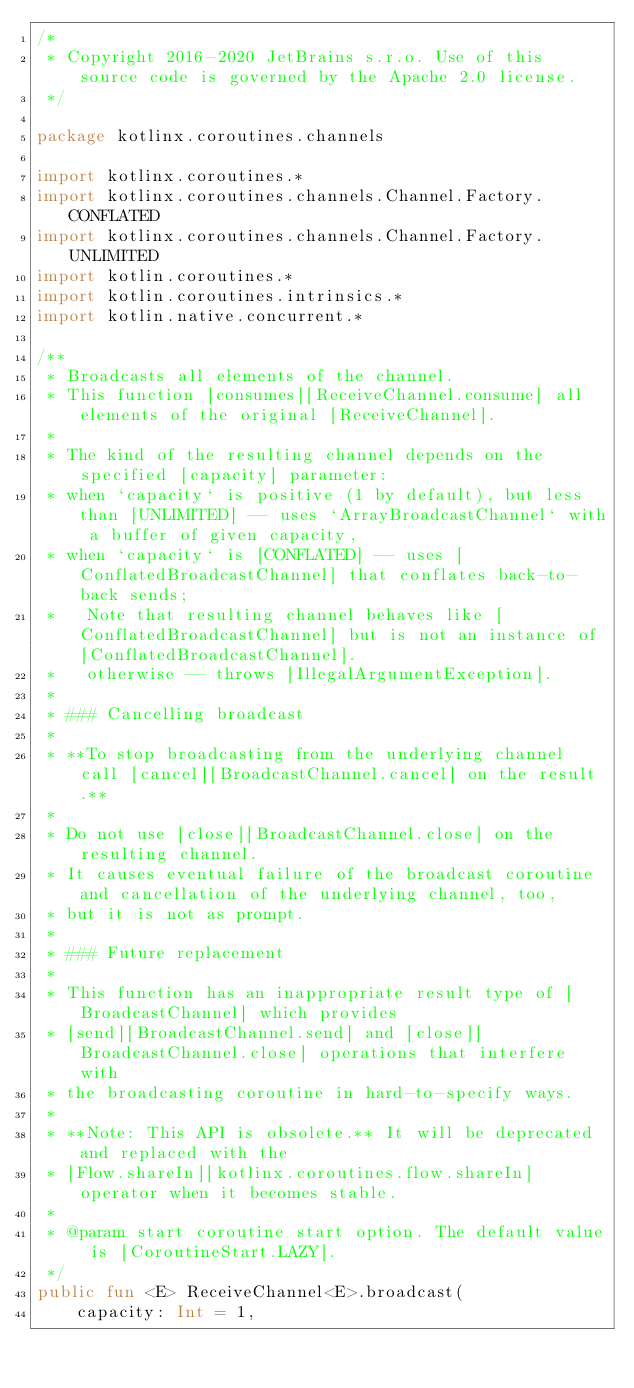<code> <loc_0><loc_0><loc_500><loc_500><_Kotlin_>/*
 * Copyright 2016-2020 JetBrains s.r.o. Use of this source code is governed by the Apache 2.0 license.
 */

package kotlinx.coroutines.channels

import kotlinx.coroutines.*
import kotlinx.coroutines.channels.Channel.Factory.CONFLATED
import kotlinx.coroutines.channels.Channel.Factory.UNLIMITED
import kotlin.coroutines.*
import kotlin.coroutines.intrinsics.*
import kotlin.native.concurrent.*

/**
 * Broadcasts all elements of the channel.
 * This function [consumes][ReceiveChannel.consume] all elements of the original [ReceiveChannel].
 *
 * The kind of the resulting channel depends on the specified [capacity] parameter:
 * when `capacity` is positive (1 by default), but less than [UNLIMITED] -- uses `ArrayBroadcastChannel` with a buffer of given capacity,
 * when `capacity` is [CONFLATED] -- uses [ConflatedBroadcastChannel] that conflates back-to-back sends;
 *   Note that resulting channel behaves like [ConflatedBroadcastChannel] but is not an instance of [ConflatedBroadcastChannel].
 *   otherwise -- throws [IllegalArgumentException].
 *
 * ### Cancelling broadcast
 *
 * **To stop broadcasting from the underlying channel call [cancel][BroadcastChannel.cancel] on the result.**
 *
 * Do not use [close][BroadcastChannel.close] on the resulting channel.
 * It causes eventual failure of the broadcast coroutine and cancellation of the underlying channel, too,
 * but it is not as prompt.
 *
 * ### Future replacement
 *
 * This function has an inappropriate result type of [BroadcastChannel] which provides
 * [send][BroadcastChannel.send] and [close][BroadcastChannel.close] operations that interfere with
 * the broadcasting coroutine in hard-to-specify ways.
 *
 * **Note: This API is obsolete.** It will be deprecated and replaced with the
 * [Flow.shareIn][kotlinx.coroutines.flow.shareIn] operator when it becomes stable.
 *
 * @param start coroutine start option. The default value is [CoroutineStart.LAZY].
 */
public fun <E> ReceiveChannel<E>.broadcast(
    capacity: Int = 1,</code> 